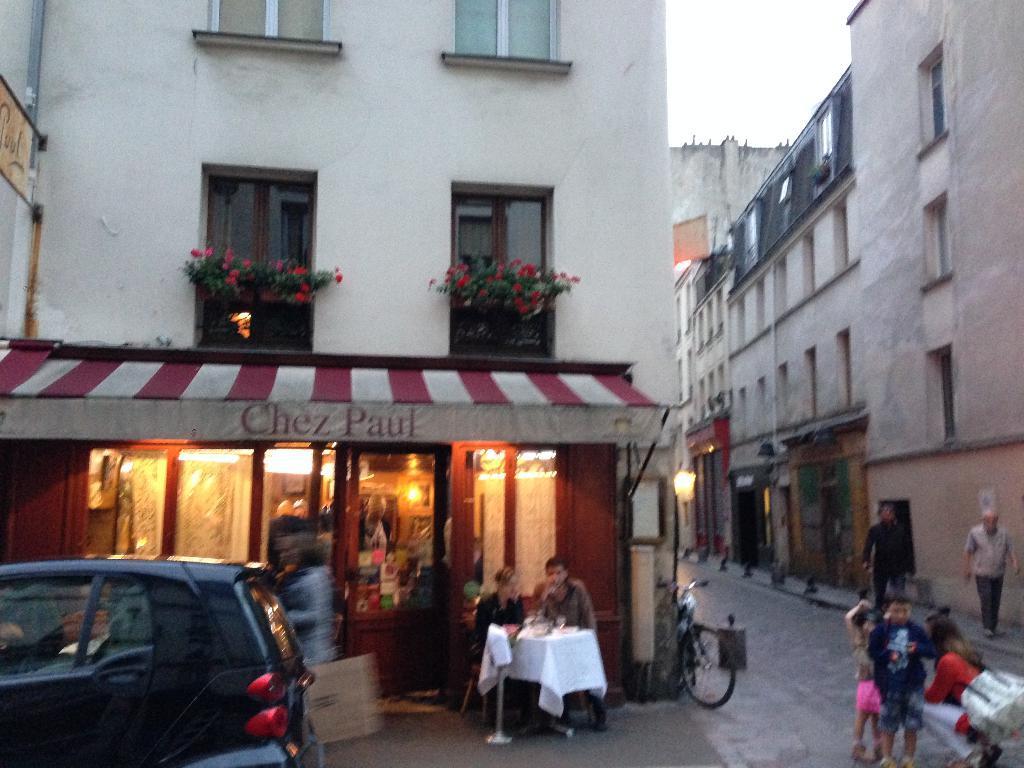Describe this image in one or two sentences. In the foreground I can see vehicles, table, chairs and a group of people on the road. In the background I can see buildings, houseplants, windows, lights, doors and the sky. This image is taken may be on the road. 